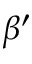Convert formula to latex. <formula><loc_0><loc_0><loc_500><loc_500>\beta ^ { \prime }</formula> 